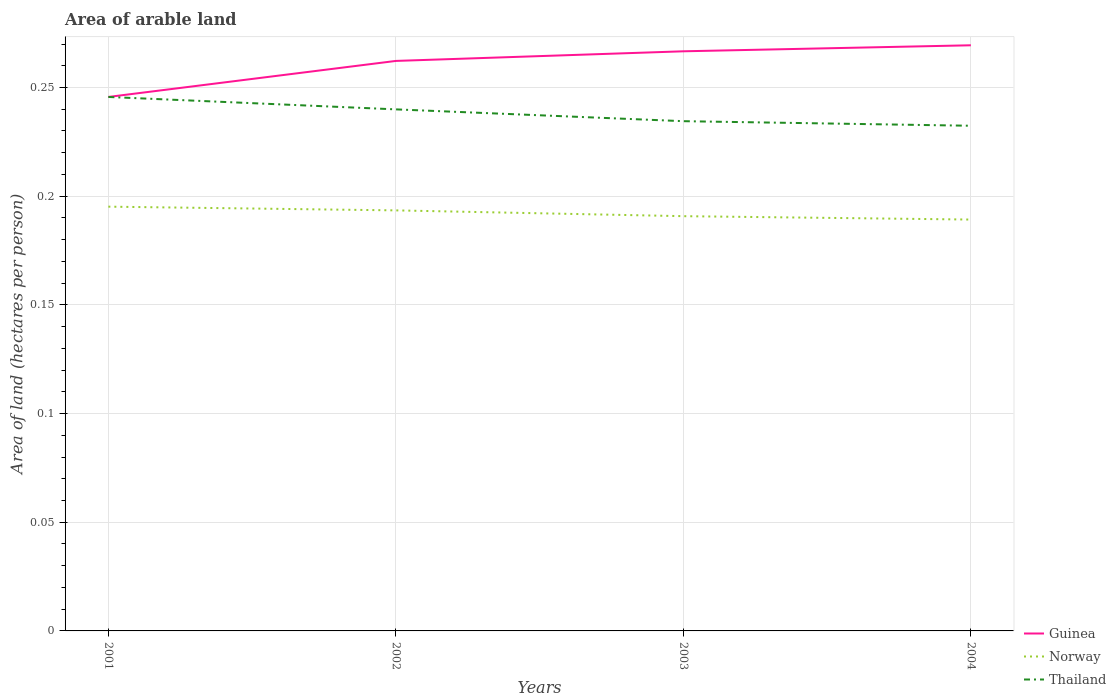Across all years, what is the maximum total arable land in Guinea?
Your answer should be very brief. 0.25. What is the total total arable land in Guinea in the graph?
Make the answer very short. -0.01. What is the difference between the highest and the second highest total arable land in Norway?
Your response must be concise. 0.01. What is the difference between the highest and the lowest total arable land in Norway?
Provide a short and direct response. 2. How many years are there in the graph?
Ensure brevity in your answer.  4. Does the graph contain any zero values?
Your answer should be very brief. No. How are the legend labels stacked?
Your response must be concise. Vertical. What is the title of the graph?
Make the answer very short. Area of arable land. What is the label or title of the X-axis?
Provide a succinct answer. Years. What is the label or title of the Y-axis?
Give a very brief answer. Area of land (hectares per person). What is the Area of land (hectares per person) in Guinea in 2001?
Give a very brief answer. 0.25. What is the Area of land (hectares per person) of Norway in 2001?
Your response must be concise. 0.2. What is the Area of land (hectares per person) of Thailand in 2001?
Give a very brief answer. 0.25. What is the Area of land (hectares per person) of Guinea in 2002?
Provide a succinct answer. 0.26. What is the Area of land (hectares per person) in Norway in 2002?
Give a very brief answer. 0.19. What is the Area of land (hectares per person) in Thailand in 2002?
Give a very brief answer. 0.24. What is the Area of land (hectares per person) in Guinea in 2003?
Your response must be concise. 0.27. What is the Area of land (hectares per person) of Norway in 2003?
Provide a short and direct response. 0.19. What is the Area of land (hectares per person) of Thailand in 2003?
Make the answer very short. 0.23. What is the Area of land (hectares per person) of Guinea in 2004?
Keep it short and to the point. 0.27. What is the Area of land (hectares per person) in Norway in 2004?
Give a very brief answer. 0.19. What is the Area of land (hectares per person) in Thailand in 2004?
Your response must be concise. 0.23. Across all years, what is the maximum Area of land (hectares per person) in Guinea?
Offer a very short reply. 0.27. Across all years, what is the maximum Area of land (hectares per person) of Norway?
Your response must be concise. 0.2. Across all years, what is the maximum Area of land (hectares per person) in Thailand?
Your response must be concise. 0.25. Across all years, what is the minimum Area of land (hectares per person) of Guinea?
Provide a short and direct response. 0.25. Across all years, what is the minimum Area of land (hectares per person) in Norway?
Provide a short and direct response. 0.19. Across all years, what is the minimum Area of land (hectares per person) of Thailand?
Provide a succinct answer. 0.23. What is the total Area of land (hectares per person) of Guinea in the graph?
Your answer should be very brief. 1.04. What is the total Area of land (hectares per person) in Norway in the graph?
Make the answer very short. 0.77. What is the total Area of land (hectares per person) of Thailand in the graph?
Offer a very short reply. 0.95. What is the difference between the Area of land (hectares per person) of Guinea in 2001 and that in 2002?
Keep it short and to the point. -0.02. What is the difference between the Area of land (hectares per person) in Norway in 2001 and that in 2002?
Provide a short and direct response. 0. What is the difference between the Area of land (hectares per person) of Thailand in 2001 and that in 2002?
Give a very brief answer. 0.01. What is the difference between the Area of land (hectares per person) in Guinea in 2001 and that in 2003?
Offer a very short reply. -0.02. What is the difference between the Area of land (hectares per person) in Norway in 2001 and that in 2003?
Provide a short and direct response. 0. What is the difference between the Area of land (hectares per person) of Thailand in 2001 and that in 2003?
Keep it short and to the point. 0.01. What is the difference between the Area of land (hectares per person) in Guinea in 2001 and that in 2004?
Keep it short and to the point. -0.02. What is the difference between the Area of land (hectares per person) in Norway in 2001 and that in 2004?
Your answer should be compact. 0.01. What is the difference between the Area of land (hectares per person) in Thailand in 2001 and that in 2004?
Provide a succinct answer. 0.01. What is the difference between the Area of land (hectares per person) in Guinea in 2002 and that in 2003?
Your answer should be compact. -0. What is the difference between the Area of land (hectares per person) in Norway in 2002 and that in 2003?
Your response must be concise. 0. What is the difference between the Area of land (hectares per person) of Thailand in 2002 and that in 2003?
Your answer should be compact. 0.01. What is the difference between the Area of land (hectares per person) in Guinea in 2002 and that in 2004?
Ensure brevity in your answer.  -0.01. What is the difference between the Area of land (hectares per person) in Norway in 2002 and that in 2004?
Provide a succinct answer. 0. What is the difference between the Area of land (hectares per person) of Thailand in 2002 and that in 2004?
Make the answer very short. 0.01. What is the difference between the Area of land (hectares per person) of Guinea in 2003 and that in 2004?
Provide a short and direct response. -0. What is the difference between the Area of land (hectares per person) in Norway in 2003 and that in 2004?
Keep it short and to the point. 0. What is the difference between the Area of land (hectares per person) of Thailand in 2003 and that in 2004?
Offer a very short reply. 0. What is the difference between the Area of land (hectares per person) in Guinea in 2001 and the Area of land (hectares per person) in Norway in 2002?
Your response must be concise. 0.05. What is the difference between the Area of land (hectares per person) in Guinea in 2001 and the Area of land (hectares per person) in Thailand in 2002?
Your answer should be compact. 0.01. What is the difference between the Area of land (hectares per person) in Norway in 2001 and the Area of land (hectares per person) in Thailand in 2002?
Offer a terse response. -0.04. What is the difference between the Area of land (hectares per person) in Guinea in 2001 and the Area of land (hectares per person) in Norway in 2003?
Your response must be concise. 0.05. What is the difference between the Area of land (hectares per person) in Guinea in 2001 and the Area of land (hectares per person) in Thailand in 2003?
Make the answer very short. 0.01. What is the difference between the Area of land (hectares per person) in Norway in 2001 and the Area of land (hectares per person) in Thailand in 2003?
Your answer should be very brief. -0.04. What is the difference between the Area of land (hectares per person) of Guinea in 2001 and the Area of land (hectares per person) of Norway in 2004?
Your answer should be very brief. 0.06. What is the difference between the Area of land (hectares per person) of Guinea in 2001 and the Area of land (hectares per person) of Thailand in 2004?
Your answer should be very brief. 0.01. What is the difference between the Area of land (hectares per person) in Norway in 2001 and the Area of land (hectares per person) in Thailand in 2004?
Provide a succinct answer. -0.04. What is the difference between the Area of land (hectares per person) of Guinea in 2002 and the Area of land (hectares per person) of Norway in 2003?
Make the answer very short. 0.07. What is the difference between the Area of land (hectares per person) of Guinea in 2002 and the Area of land (hectares per person) of Thailand in 2003?
Make the answer very short. 0.03. What is the difference between the Area of land (hectares per person) in Norway in 2002 and the Area of land (hectares per person) in Thailand in 2003?
Your answer should be compact. -0.04. What is the difference between the Area of land (hectares per person) of Guinea in 2002 and the Area of land (hectares per person) of Norway in 2004?
Offer a very short reply. 0.07. What is the difference between the Area of land (hectares per person) in Guinea in 2002 and the Area of land (hectares per person) in Thailand in 2004?
Offer a terse response. 0.03. What is the difference between the Area of land (hectares per person) in Norway in 2002 and the Area of land (hectares per person) in Thailand in 2004?
Offer a terse response. -0.04. What is the difference between the Area of land (hectares per person) in Guinea in 2003 and the Area of land (hectares per person) in Norway in 2004?
Provide a succinct answer. 0.08. What is the difference between the Area of land (hectares per person) of Guinea in 2003 and the Area of land (hectares per person) of Thailand in 2004?
Your answer should be very brief. 0.03. What is the difference between the Area of land (hectares per person) in Norway in 2003 and the Area of land (hectares per person) in Thailand in 2004?
Ensure brevity in your answer.  -0.04. What is the average Area of land (hectares per person) in Guinea per year?
Provide a short and direct response. 0.26. What is the average Area of land (hectares per person) of Norway per year?
Offer a terse response. 0.19. What is the average Area of land (hectares per person) in Thailand per year?
Give a very brief answer. 0.24. In the year 2001, what is the difference between the Area of land (hectares per person) in Guinea and Area of land (hectares per person) in Norway?
Provide a short and direct response. 0.05. In the year 2001, what is the difference between the Area of land (hectares per person) in Norway and Area of land (hectares per person) in Thailand?
Provide a short and direct response. -0.05. In the year 2002, what is the difference between the Area of land (hectares per person) of Guinea and Area of land (hectares per person) of Norway?
Ensure brevity in your answer.  0.07. In the year 2002, what is the difference between the Area of land (hectares per person) in Guinea and Area of land (hectares per person) in Thailand?
Provide a succinct answer. 0.02. In the year 2002, what is the difference between the Area of land (hectares per person) in Norway and Area of land (hectares per person) in Thailand?
Offer a terse response. -0.05. In the year 2003, what is the difference between the Area of land (hectares per person) of Guinea and Area of land (hectares per person) of Norway?
Your answer should be compact. 0.08. In the year 2003, what is the difference between the Area of land (hectares per person) in Guinea and Area of land (hectares per person) in Thailand?
Provide a short and direct response. 0.03. In the year 2003, what is the difference between the Area of land (hectares per person) of Norway and Area of land (hectares per person) of Thailand?
Keep it short and to the point. -0.04. In the year 2004, what is the difference between the Area of land (hectares per person) of Guinea and Area of land (hectares per person) of Norway?
Offer a very short reply. 0.08. In the year 2004, what is the difference between the Area of land (hectares per person) of Guinea and Area of land (hectares per person) of Thailand?
Your response must be concise. 0.04. In the year 2004, what is the difference between the Area of land (hectares per person) in Norway and Area of land (hectares per person) in Thailand?
Offer a terse response. -0.04. What is the ratio of the Area of land (hectares per person) in Guinea in 2001 to that in 2002?
Your response must be concise. 0.94. What is the ratio of the Area of land (hectares per person) in Norway in 2001 to that in 2002?
Offer a terse response. 1.01. What is the ratio of the Area of land (hectares per person) in Thailand in 2001 to that in 2002?
Give a very brief answer. 1.02. What is the ratio of the Area of land (hectares per person) of Guinea in 2001 to that in 2003?
Offer a terse response. 0.92. What is the ratio of the Area of land (hectares per person) in Norway in 2001 to that in 2003?
Keep it short and to the point. 1.02. What is the ratio of the Area of land (hectares per person) in Thailand in 2001 to that in 2003?
Offer a very short reply. 1.05. What is the ratio of the Area of land (hectares per person) of Guinea in 2001 to that in 2004?
Offer a very short reply. 0.91. What is the ratio of the Area of land (hectares per person) in Norway in 2001 to that in 2004?
Keep it short and to the point. 1.03. What is the ratio of the Area of land (hectares per person) in Thailand in 2001 to that in 2004?
Give a very brief answer. 1.06. What is the ratio of the Area of land (hectares per person) in Guinea in 2002 to that in 2003?
Your response must be concise. 0.98. What is the ratio of the Area of land (hectares per person) in Thailand in 2002 to that in 2003?
Make the answer very short. 1.02. What is the ratio of the Area of land (hectares per person) in Guinea in 2002 to that in 2004?
Give a very brief answer. 0.97. What is the ratio of the Area of land (hectares per person) in Norway in 2002 to that in 2004?
Your response must be concise. 1.02. What is the ratio of the Area of land (hectares per person) in Thailand in 2002 to that in 2004?
Make the answer very short. 1.03. What is the ratio of the Area of land (hectares per person) of Guinea in 2003 to that in 2004?
Offer a terse response. 0.99. What is the ratio of the Area of land (hectares per person) in Norway in 2003 to that in 2004?
Keep it short and to the point. 1.01. What is the ratio of the Area of land (hectares per person) in Thailand in 2003 to that in 2004?
Provide a short and direct response. 1.01. What is the difference between the highest and the second highest Area of land (hectares per person) in Guinea?
Offer a terse response. 0. What is the difference between the highest and the second highest Area of land (hectares per person) of Norway?
Your response must be concise. 0. What is the difference between the highest and the second highest Area of land (hectares per person) in Thailand?
Offer a terse response. 0.01. What is the difference between the highest and the lowest Area of land (hectares per person) of Guinea?
Provide a short and direct response. 0.02. What is the difference between the highest and the lowest Area of land (hectares per person) in Norway?
Your answer should be compact. 0.01. What is the difference between the highest and the lowest Area of land (hectares per person) in Thailand?
Keep it short and to the point. 0.01. 